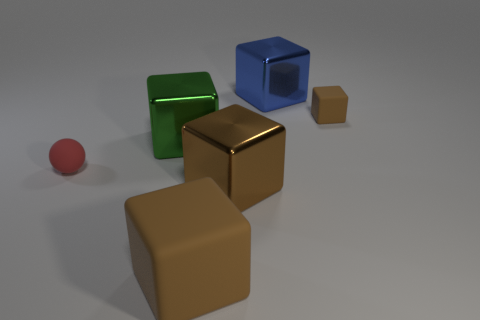How many brown cubes must be subtracted to get 1 brown cubes? 2 Subtract all green spheres. How many brown blocks are left? 3 Subtract 2 cubes. How many cubes are left? 3 Subtract all blue metal blocks. How many blocks are left? 4 Subtract all cyan blocks. Subtract all red cylinders. How many blocks are left? 5 Add 3 blue shiny things. How many objects exist? 9 Subtract all cubes. How many objects are left? 1 Add 1 big yellow matte objects. How many big yellow matte objects exist? 1 Subtract 0 brown spheres. How many objects are left? 6 Subtract all green shiny cubes. Subtract all green metal cubes. How many objects are left? 4 